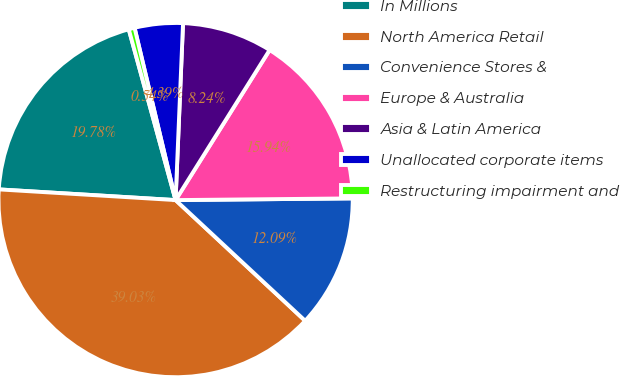Convert chart to OTSL. <chart><loc_0><loc_0><loc_500><loc_500><pie_chart><fcel>In Millions<fcel>North America Retail<fcel>Convenience Stores &<fcel>Europe & Australia<fcel>Asia & Latin America<fcel>Unallocated corporate items<fcel>Restructuring impairment and<nl><fcel>19.78%<fcel>39.03%<fcel>12.09%<fcel>15.94%<fcel>8.24%<fcel>4.39%<fcel>0.54%<nl></chart> 